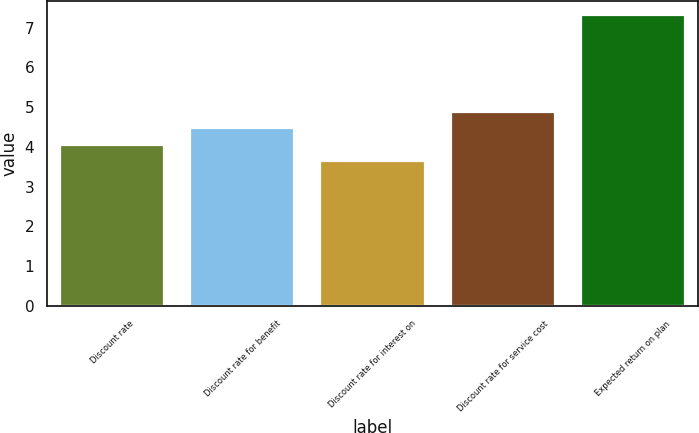Convert chart to OTSL. <chart><loc_0><loc_0><loc_500><loc_500><bar_chart><fcel>Discount rate<fcel>Discount rate for benefit<fcel>Discount rate for interest on<fcel>Discount rate for service cost<fcel>Expected return on plan<nl><fcel>4.06<fcel>4.47<fcel>3.65<fcel>4.88<fcel>7.31<nl></chart> 